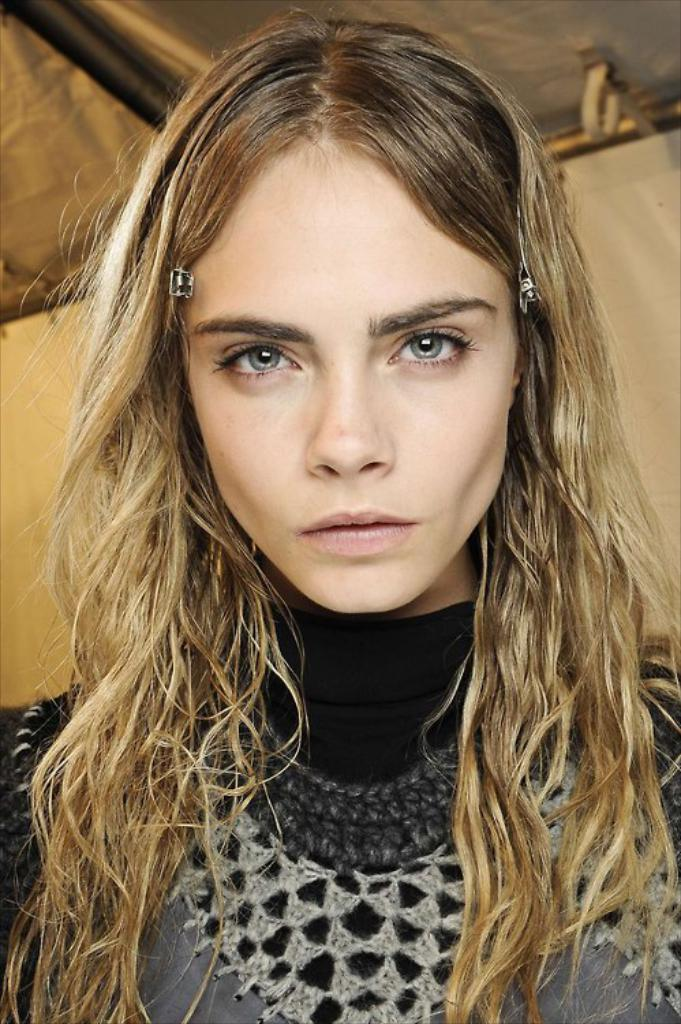Who or what can be seen in the image? There is a person in the image. What is the person's location in the image? The person is standing under a tent. What is the price of the rose in the image? There is no rose present in the image, so it is not possible to determine its price. 